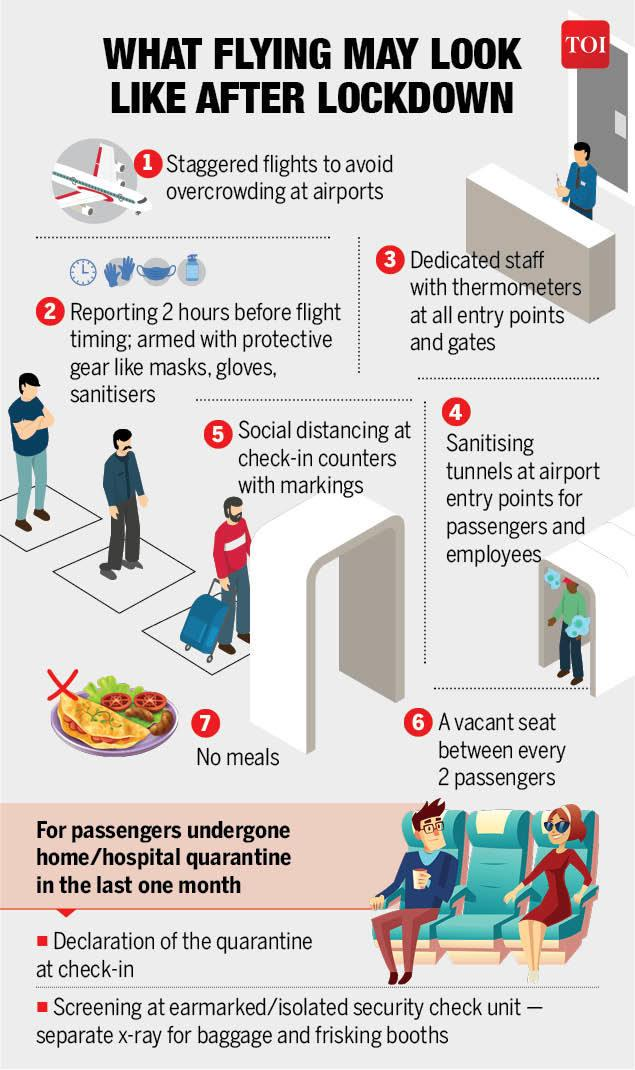List a handful of essential elements in this visual. The infographic shows 7 individuals. 